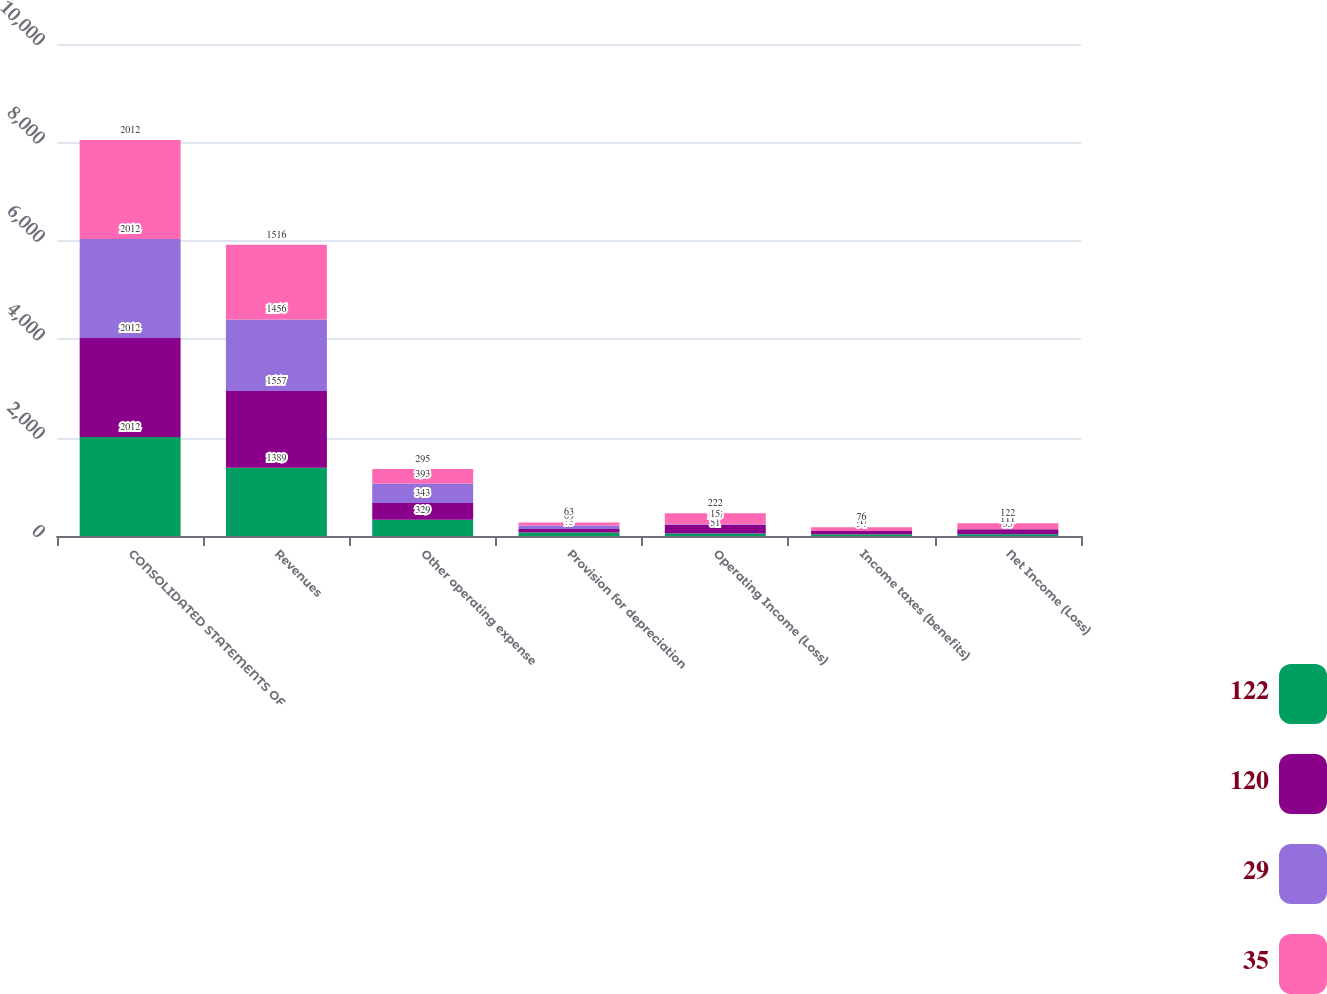<chart> <loc_0><loc_0><loc_500><loc_500><stacked_bar_chart><ecel><fcel>CONSOLIDATED STATEMENTS OF<fcel>Revenues<fcel>Other operating expense<fcel>Provision for depreciation<fcel>Operating Income (Loss)<fcel>Income taxes (benefits)<fcel>Net Income (Loss)<nl><fcel>122<fcel>2012<fcel>1389<fcel>329<fcel>73<fcel>51<fcel>34<fcel>35<nl><fcel>120<fcel>2012<fcel>1557<fcel>343<fcel>71<fcel>175<fcel>68<fcel>101<nl><fcel>29<fcel>2012<fcel>1456<fcel>393<fcel>69<fcel>15<fcel>1<fcel>1<nl><fcel>35<fcel>2012<fcel>1516<fcel>295<fcel>63<fcel>222<fcel>76<fcel>122<nl></chart> 